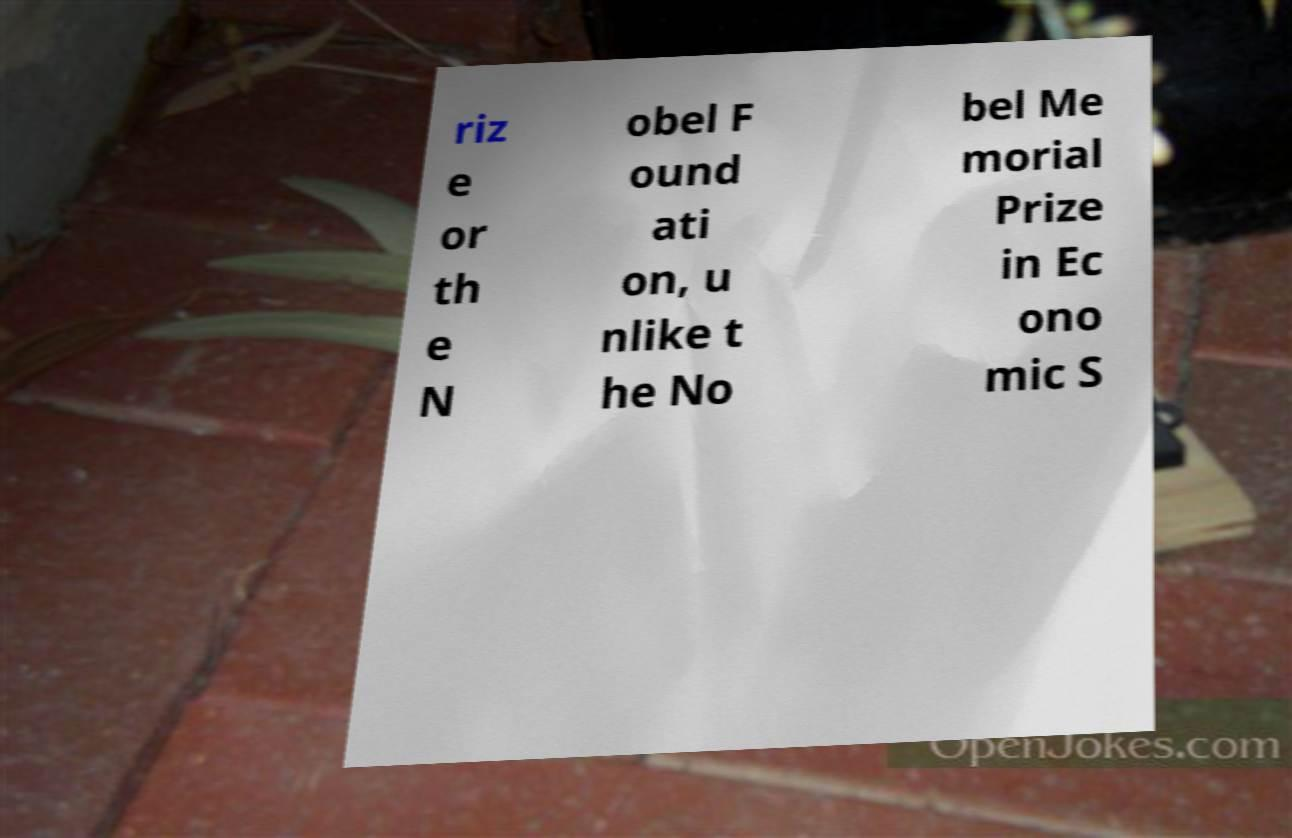For documentation purposes, I need the text within this image transcribed. Could you provide that? riz e or th e N obel F ound ati on, u nlike t he No bel Me morial Prize in Ec ono mic S 